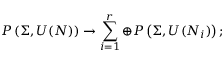<formula> <loc_0><loc_0><loc_500><loc_500>P \left ( \Sigma , U ( N ) \right ) \rightarrow \sum _ { i = 1 } ^ { r } \oplus P \left ( \Sigma , U ( N _ { i } ) \right ) ;</formula> 